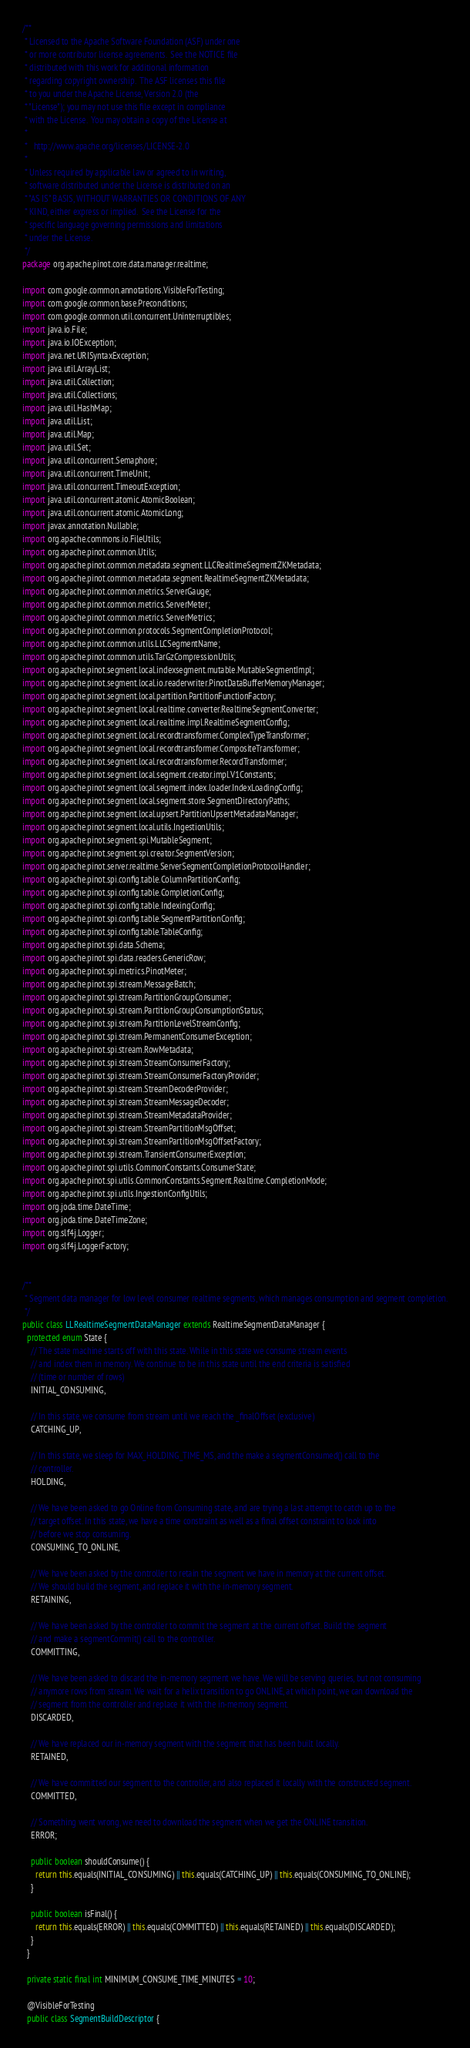<code> <loc_0><loc_0><loc_500><loc_500><_Java_>/**
 * Licensed to the Apache Software Foundation (ASF) under one
 * or more contributor license agreements.  See the NOTICE file
 * distributed with this work for additional information
 * regarding copyright ownership.  The ASF licenses this file
 * to you under the Apache License, Version 2.0 (the
 * "License"); you may not use this file except in compliance
 * with the License.  You may obtain a copy of the License at
 *
 *   http://www.apache.org/licenses/LICENSE-2.0
 *
 * Unless required by applicable law or agreed to in writing,
 * software distributed under the License is distributed on an
 * "AS IS" BASIS, WITHOUT WARRANTIES OR CONDITIONS OF ANY
 * KIND, either express or implied.  See the License for the
 * specific language governing permissions and limitations
 * under the License.
 */
package org.apache.pinot.core.data.manager.realtime;

import com.google.common.annotations.VisibleForTesting;
import com.google.common.base.Preconditions;
import com.google.common.util.concurrent.Uninterruptibles;
import java.io.File;
import java.io.IOException;
import java.net.URISyntaxException;
import java.util.ArrayList;
import java.util.Collection;
import java.util.Collections;
import java.util.HashMap;
import java.util.List;
import java.util.Map;
import java.util.Set;
import java.util.concurrent.Semaphore;
import java.util.concurrent.TimeUnit;
import java.util.concurrent.TimeoutException;
import java.util.concurrent.atomic.AtomicBoolean;
import java.util.concurrent.atomic.AtomicLong;
import javax.annotation.Nullable;
import org.apache.commons.io.FileUtils;
import org.apache.pinot.common.Utils;
import org.apache.pinot.common.metadata.segment.LLCRealtimeSegmentZKMetadata;
import org.apache.pinot.common.metadata.segment.RealtimeSegmentZKMetadata;
import org.apache.pinot.common.metrics.ServerGauge;
import org.apache.pinot.common.metrics.ServerMeter;
import org.apache.pinot.common.metrics.ServerMetrics;
import org.apache.pinot.common.protocols.SegmentCompletionProtocol;
import org.apache.pinot.common.utils.LLCSegmentName;
import org.apache.pinot.common.utils.TarGzCompressionUtils;
import org.apache.pinot.segment.local.indexsegment.mutable.MutableSegmentImpl;
import org.apache.pinot.segment.local.io.readerwriter.PinotDataBufferMemoryManager;
import org.apache.pinot.segment.local.partition.PartitionFunctionFactory;
import org.apache.pinot.segment.local.realtime.converter.RealtimeSegmentConverter;
import org.apache.pinot.segment.local.realtime.impl.RealtimeSegmentConfig;
import org.apache.pinot.segment.local.recordtransformer.ComplexTypeTransformer;
import org.apache.pinot.segment.local.recordtransformer.CompositeTransformer;
import org.apache.pinot.segment.local.recordtransformer.RecordTransformer;
import org.apache.pinot.segment.local.segment.creator.impl.V1Constants;
import org.apache.pinot.segment.local.segment.index.loader.IndexLoadingConfig;
import org.apache.pinot.segment.local.segment.store.SegmentDirectoryPaths;
import org.apache.pinot.segment.local.upsert.PartitionUpsertMetadataManager;
import org.apache.pinot.segment.local.utils.IngestionUtils;
import org.apache.pinot.segment.spi.MutableSegment;
import org.apache.pinot.segment.spi.creator.SegmentVersion;
import org.apache.pinot.server.realtime.ServerSegmentCompletionProtocolHandler;
import org.apache.pinot.spi.config.table.ColumnPartitionConfig;
import org.apache.pinot.spi.config.table.CompletionConfig;
import org.apache.pinot.spi.config.table.IndexingConfig;
import org.apache.pinot.spi.config.table.SegmentPartitionConfig;
import org.apache.pinot.spi.config.table.TableConfig;
import org.apache.pinot.spi.data.Schema;
import org.apache.pinot.spi.data.readers.GenericRow;
import org.apache.pinot.spi.metrics.PinotMeter;
import org.apache.pinot.spi.stream.MessageBatch;
import org.apache.pinot.spi.stream.PartitionGroupConsumer;
import org.apache.pinot.spi.stream.PartitionGroupConsumptionStatus;
import org.apache.pinot.spi.stream.PartitionLevelStreamConfig;
import org.apache.pinot.spi.stream.PermanentConsumerException;
import org.apache.pinot.spi.stream.RowMetadata;
import org.apache.pinot.spi.stream.StreamConsumerFactory;
import org.apache.pinot.spi.stream.StreamConsumerFactoryProvider;
import org.apache.pinot.spi.stream.StreamDecoderProvider;
import org.apache.pinot.spi.stream.StreamMessageDecoder;
import org.apache.pinot.spi.stream.StreamMetadataProvider;
import org.apache.pinot.spi.stream.StreamPartitionMsgOffset;
import org.apache.pinot.spi.stream.StreamPartitionMsgOffsetFactory;
import org.apache.pinot.spi.stream.TransientConsumerException;
import org.apache.pinot.spi.utils.CommonConstants.ConsumerState;
import org.apache.pinot.spi.utils.CommonConstants.Segment.Realtime.CompletionMode;
import org.apache.pinot.spi.utils.IngestionConfigUtils;
import org.joda.time.DateTime;
import org.joda.time.DateTimeZone;
import org.slf4j.Logger;
import org.slf4j.LoggerFactory;


/**
 * Segment data manager for low level consumer realtime segments, which manages consumption and segment completion.
 */
public class LLRealtimeSegmentDataManager extends RealtimeSegmentDataManager {
  protected enum State {
    // The state machine starts off with this state. While in this state we consume stream events
    // and index them in memory. We continue to be in this state until the end criteria is satisfied
    // (time or number of rows)
    INITIAL_CONSUMING,

    // In this state, we consume from stream until we reach the _finalOffset (exclusive)
    CATCHING_UP,

    // In this state, we sleep for MAX_HOLDING_TIME_MS, and the make a segmentConsumed() call to the
    // controller.
    HOLDING,

    // We have been asked to go Online from Consuming state, and are trying a last attempt to catch up to the
    // target offset. In this state, we have a time constraint as well as a final offset constraint to look into
    // before we stop consuming.
    CONSUMING_TO_ONLINE,

    // We have been asked by the controller to retain the segment we have in memory at the current offset.
    // We should build the segment, and replace it with the in-memory segment.
    RETAINING,

    // We have been asked by the controller to commit the segment at the current offset. Build the segment
    // and make a segmentCommit() call to the controller.
    COMMITTING,

    // We have been asked to discard the in-memory segment we have. We will be serving queries, but not consuming
    // anymore rows from stream. We wait for a helix transition to go ONLINE, at which point, we can download the
    // segment from the controller and replace it with the in-memory segment.
    DISCARDED,

    // We have replaced our in-memory segment with the segment that has been built locally.
    RETAINED,

    // We have committed our segment to the controller, and also replaced it locally with the constructed segment.
    COMMITTED,

    // Something went wrong, we need to download the segment when we get the ONLINE transition.
    ERROR;

    public boolean shouldConsume() {
      return this.equals(INITIAL_CONSUMING) || this.equals(CATCHING_UP) || this.equals(CONSUMING_TO_ONLINE);
    }

    public boolean isFinal() {
      return this.equals(ERROR) || this.equals(COMMITTED) || this.equals(RETAINED) || this.equals(DISCARDED);
    }
  }

  private static final int MINIMUM_CONSUME_TIME_MINUTES = 10;

  @VisibleForTesting
  public class SegmentBuildDescriptor {</code> 